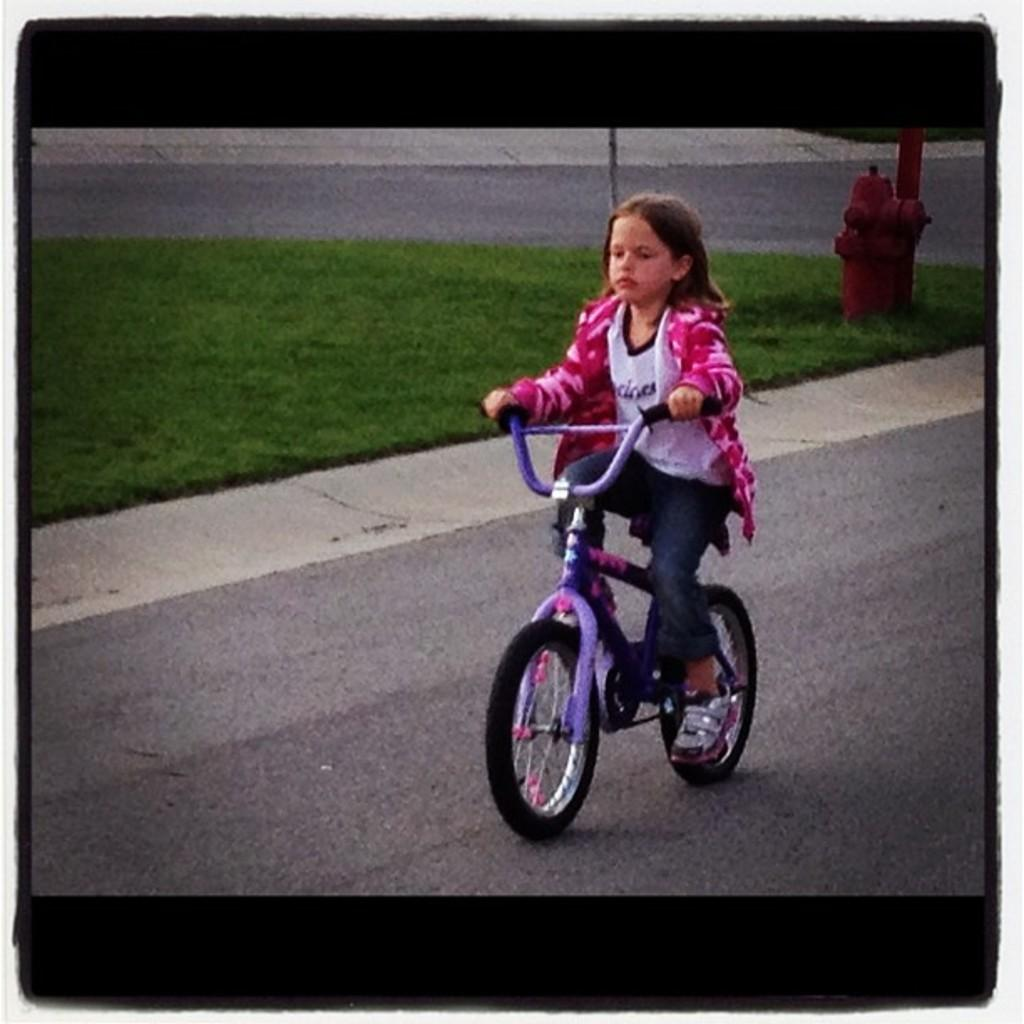Who is the main subject in the image? There is a girl in the image. What is the girl doing in the image? The girl is riding a bicycle. Can you describe the color of the bicycle? The bicycle is purple. What type of terrain is visible in the image? There is grass in the middle of the image. What object can be seen on the right side of the image? There is a water pump on the right side of the image. What is the girl's opinion on the health benefits of cycling in the image? The image does not provide any information about the girl's opinion on the health benefits of cycling. 